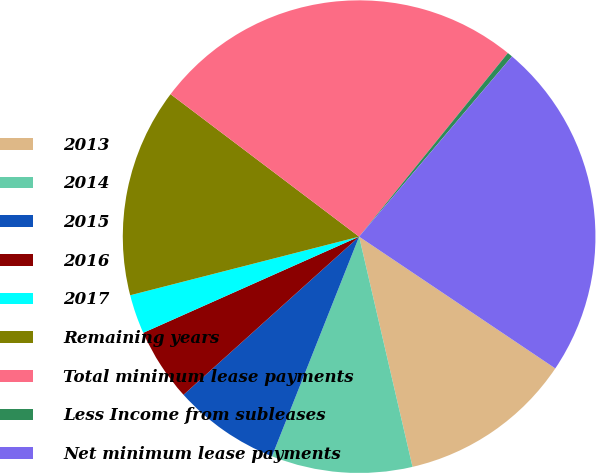Convert chart to OTSL. <chart><loc_0><loc_0><loc_500><loc_500><pie_chart><fcel>2013<fcel>2014<fcel>2015<fcel>2016<fcel>2017<fcel>Remaining years<fcel>Total minimum lease payments<fcel>Less Income from subleases<fcel>Net minimum lease payments<nl><fcel>11.96%<fcel>9.64%<fcel>7.32%<fcel>5.0%<fcel>2.68%<fcel>14.29%<fcel>25.54%<fcel>0.36%<fcel>23.22%<nl></chart> 